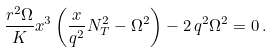<formula> <loc_0><loc_0><loc_500><loc_500>\frac { r ^ { 2 } \Omega } { K } x ^ { 3 } \left ( \frac { x } { q ^ { 2 } } N _ { T } ^ { 2 } - \Omega ^ { 2 } \right ) - 2 \, q ^ { 2 } \Omega ^ { 2 } = 0 \, .</formula> 